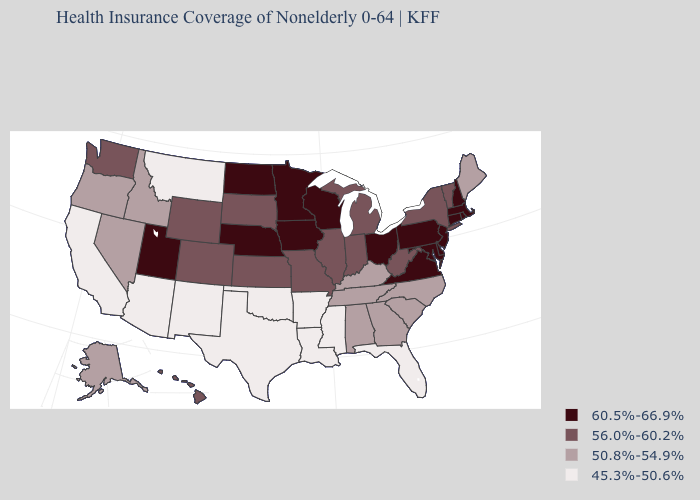Which states have the lowest value in the West?
Be succinct. Arizona, California, Montana, New Mexico. What is the lowest value in the USA?
Be succinct. 45.3%-50.6%. Among the states that border Arizona , does California have the lowest value?
Concise answer only. Yes. What is the lowest value in states that border Ohio?
Quick response, please. 50.8%-54.9%. Name the states that have a value in the range 45.3%-50.6%?
Give a very brief answer. Arizona, Arkansas, California, Florida, Louisiana, Mississippi, Montana, New Mexico, Oklahoma, Texas. Does the map have missing data?
Quick response, please. No. Name the states that have a value in the range 60.5%-66.9%?
Short answer required. Connecticut, Delaware, Iowa, Maryland, Massachusetts, Minnesota, Nebraska, New Hampshire, New Jersey, North Dakota, Ohio, Pennsylvania, Rhode Island, Utah, Virginia, Wisconsin. What is the value of Pennsylvania?
Concise answer only. 60.5%-66.9%. Name the states that have a value in the range 50.8%-54.9%?
Give a very brief answer. Alabama, Alaska, Georgia, Idaho, Kentucky, Maine, Nevada, North Carolina, Oregon, South Carolina, Tennessee. Does Virginia have the highest value in the South?
Quick response, please. Yes. Name the states that have a value in the range 60.5%-66.9%?
Quick response, please. Connecticut, Delaware, Iowa, Maryland, Massachusetts, Minnesota, Nebraska, New Hampshire, New Jersey, North Dakota, Ohio, Pennsylvania, Rhode Island, Utah, Virginia, Wisconsin. Which states hav the highest value in the West?
Quick response, please. Utah. What is the value of Arizona?
Answer briefly. 45.3%-50.6%. What is the value of Alabama?
Give a very brief answer. 50.8%-54.9%. What is the lowest value in the West?
Answer briefly. 45.3%-50.6%. 